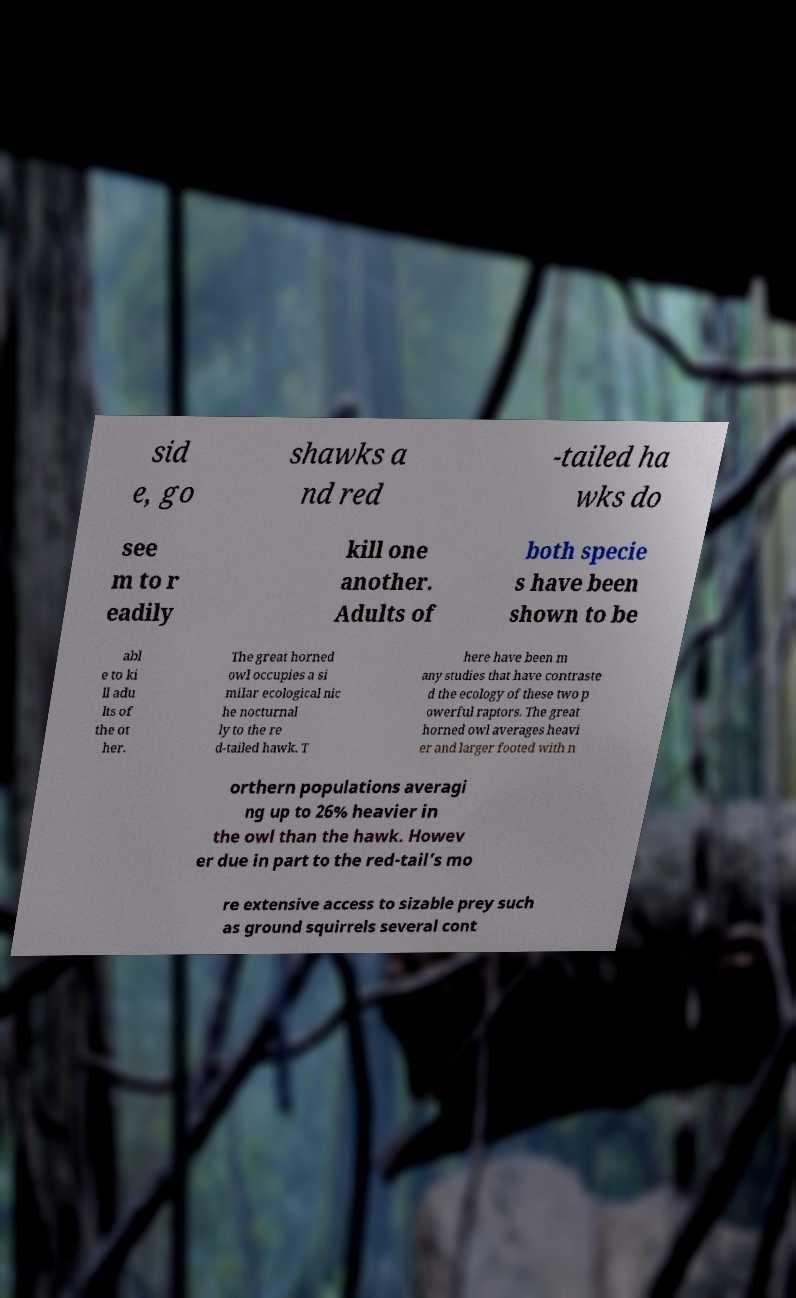Can you accurately transcribe the text from the provided image for me? sid e, go shawks a nd red -tailed ha wks do see m to r eadily kill one another. Adults of both specie s have been shown to be abl e to ki ll adu lts of the ot her. The great horned owl occupies a si milar ecological nic he nocturnal ly to the re d-tailed hawk. T here have been m any studies that have contraste d the ecology of these two p owerful raptors. The great horned owl averages heavi er and larger footed with n orthern populations averagi ng up to 26% heavier in the owl than the hawk. Howev er due in part to the red-tail’s mo re extensive access to sizable prey such as ground squirrels several cont 